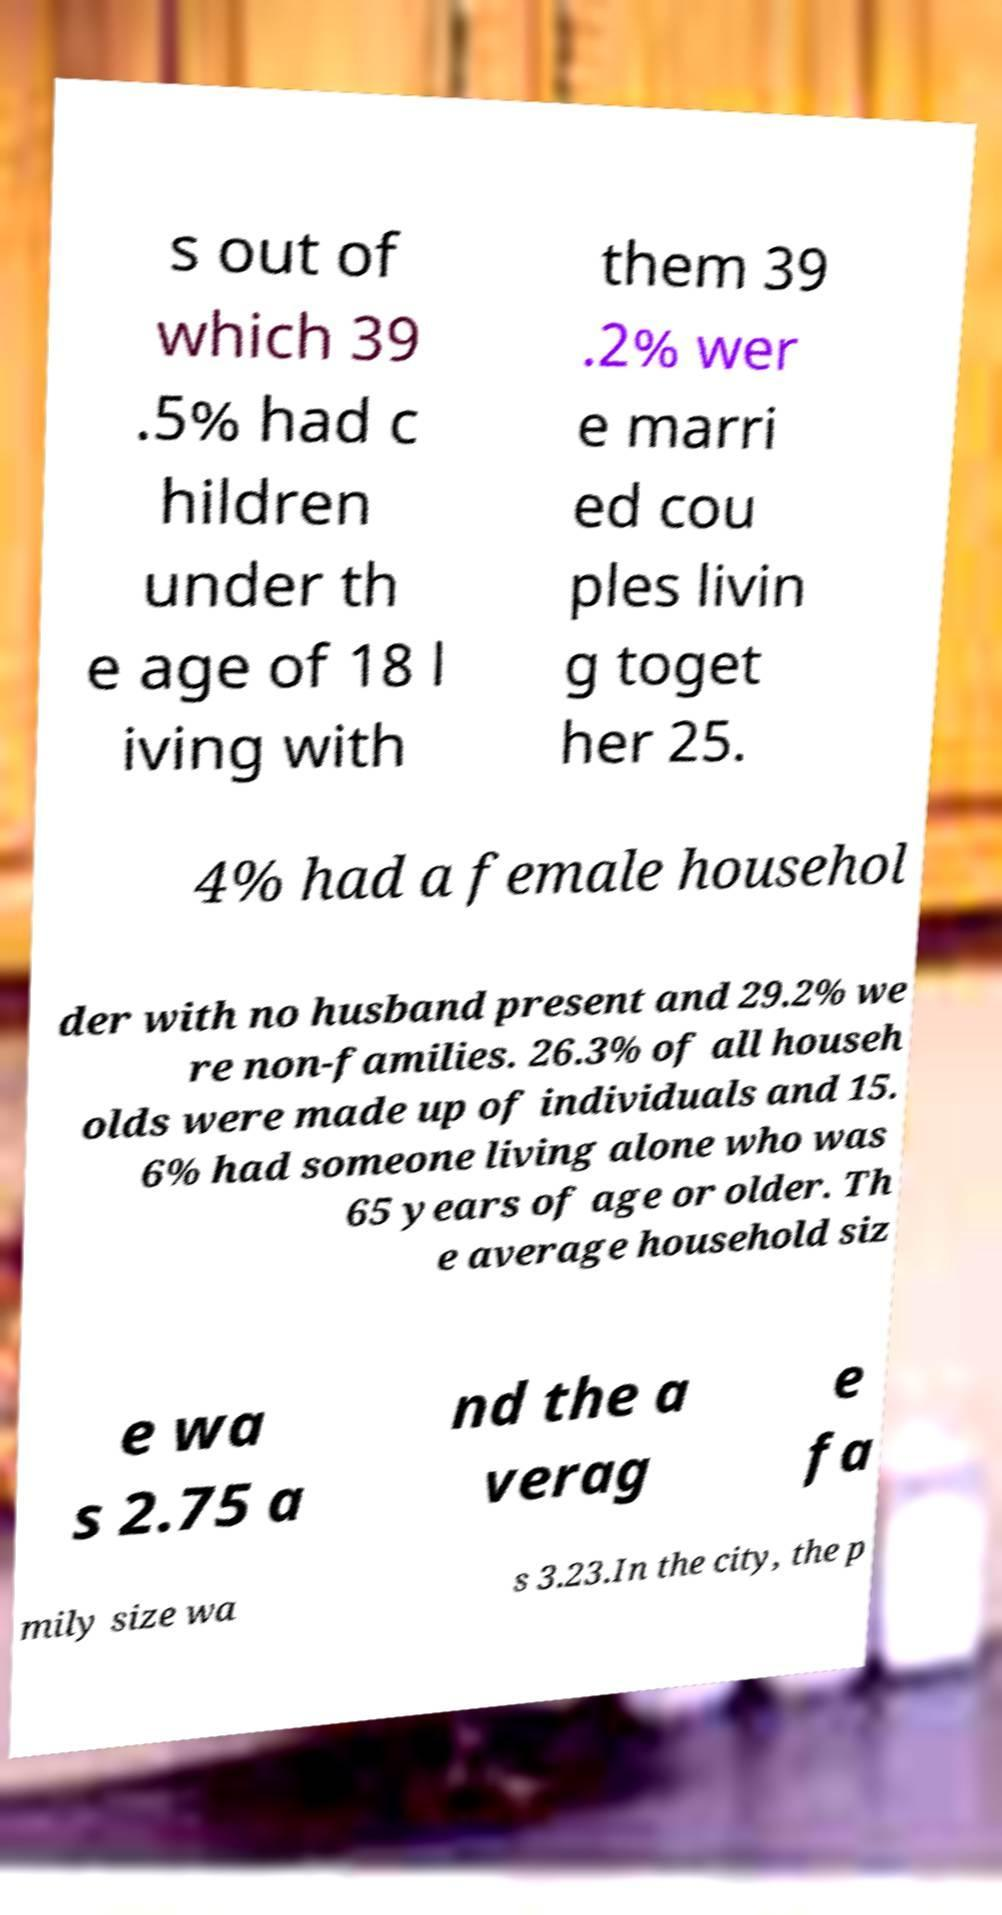Can you read and provide the text displayed in the image?This photo seems to have some interesting text. Can you extract and type it out for me? s out of which 39 .5% had c hildren under th e age of 18 l iving with them 39 .2% wer e marri ed cou ples livin g toget her 25. 4% had a female househol der with no husband present and 29.2% we re non-families. 26.3% of all househ olds were made up of individuals and 15. 6% had someone living alone who was 65 years of age or older. Th e average household siz e wa s 2.75 a nd the a verag e fa mily size wa s 3.23.In the city, the p 